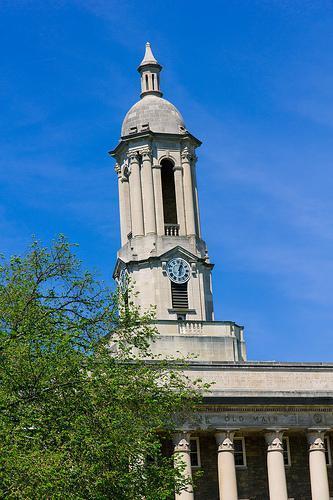How many trees are in the photo?
Give a very brief answer. 1. How many buildings are behind the tree?
Give a very brief answer. 1. How many pillars can be seen in this photo?
Give a very brief answer. 5. 